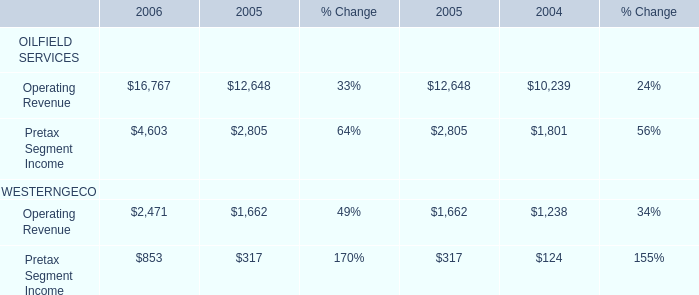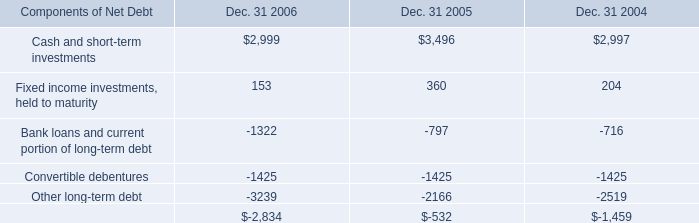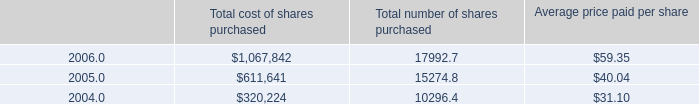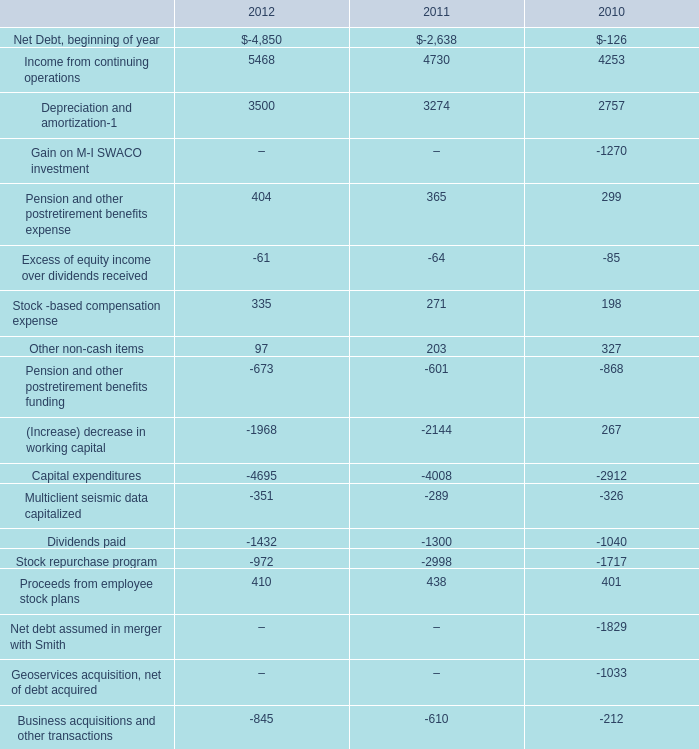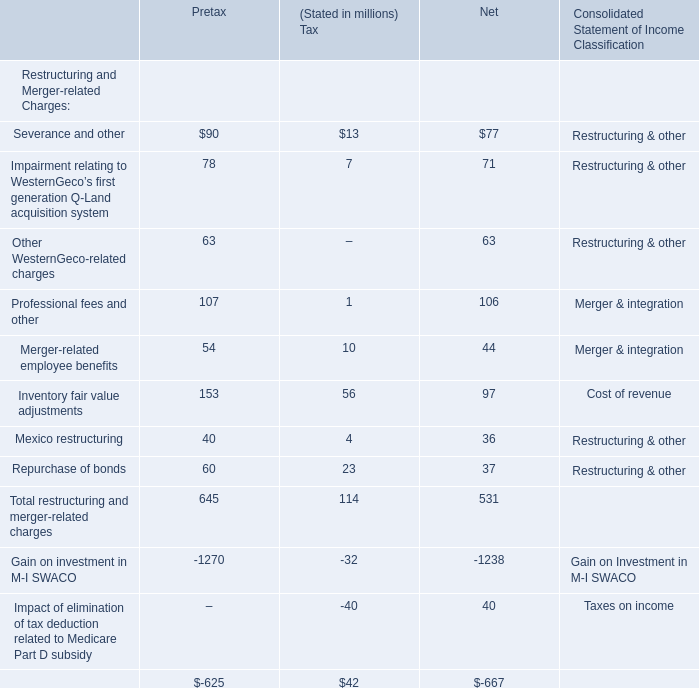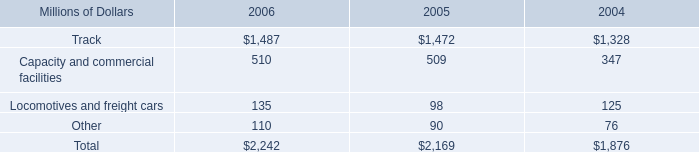What is the sum of the Net Income for Professional fees and other? 
Answer: 106. 